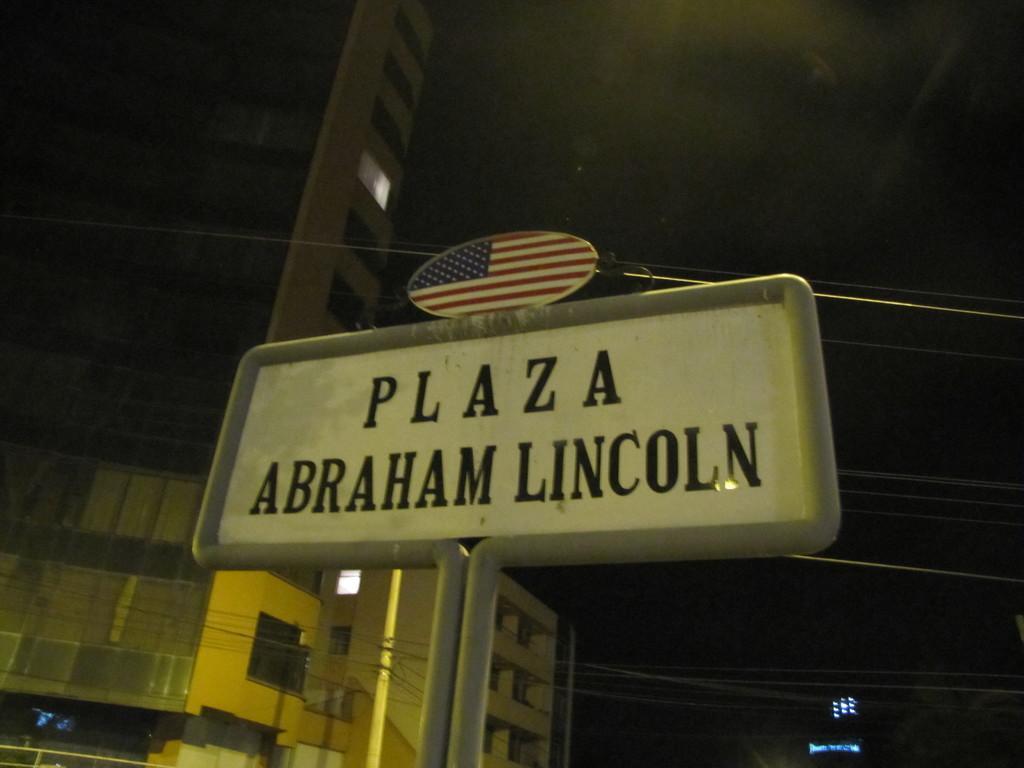Describe this image in one or two sentences. In this picture there is a board on the pole and there is a text on the board. At the back there are buildings and wires and there are lights inside the buildings. At the top there is sky. 